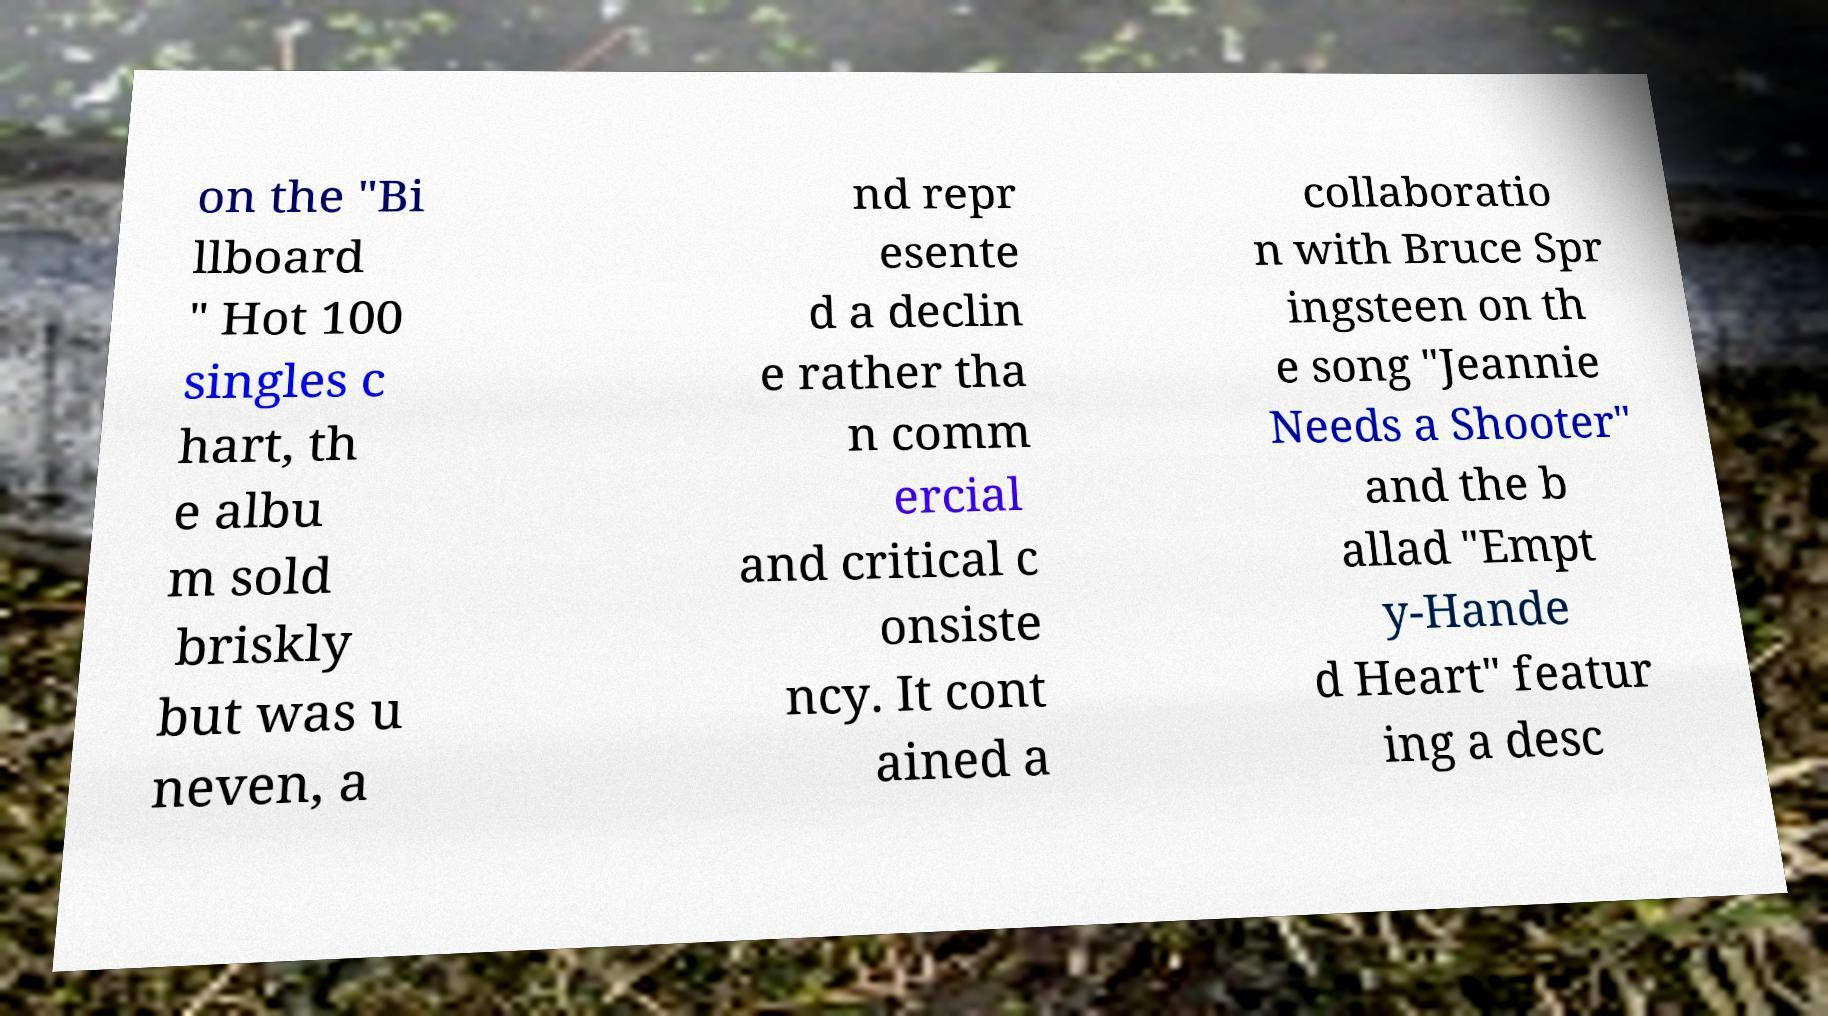Can you read and provide the text displayed in the image?This photo seems to have some interesting text. Can you extract and type it out for me? on the "Bi llboard " Hot 100 singles c hart, th e albu m sold briskly but was u neven, a nd repr esente d a declin e rather tha n comm ercial and critical c onsiste ncy. It cont ained a collaboratio n with Bruce Spr ingsteen on th e song "Jeannie Needs a Shooter" and the b allad "Empt y-Hande d Heart" featur ing a desc 